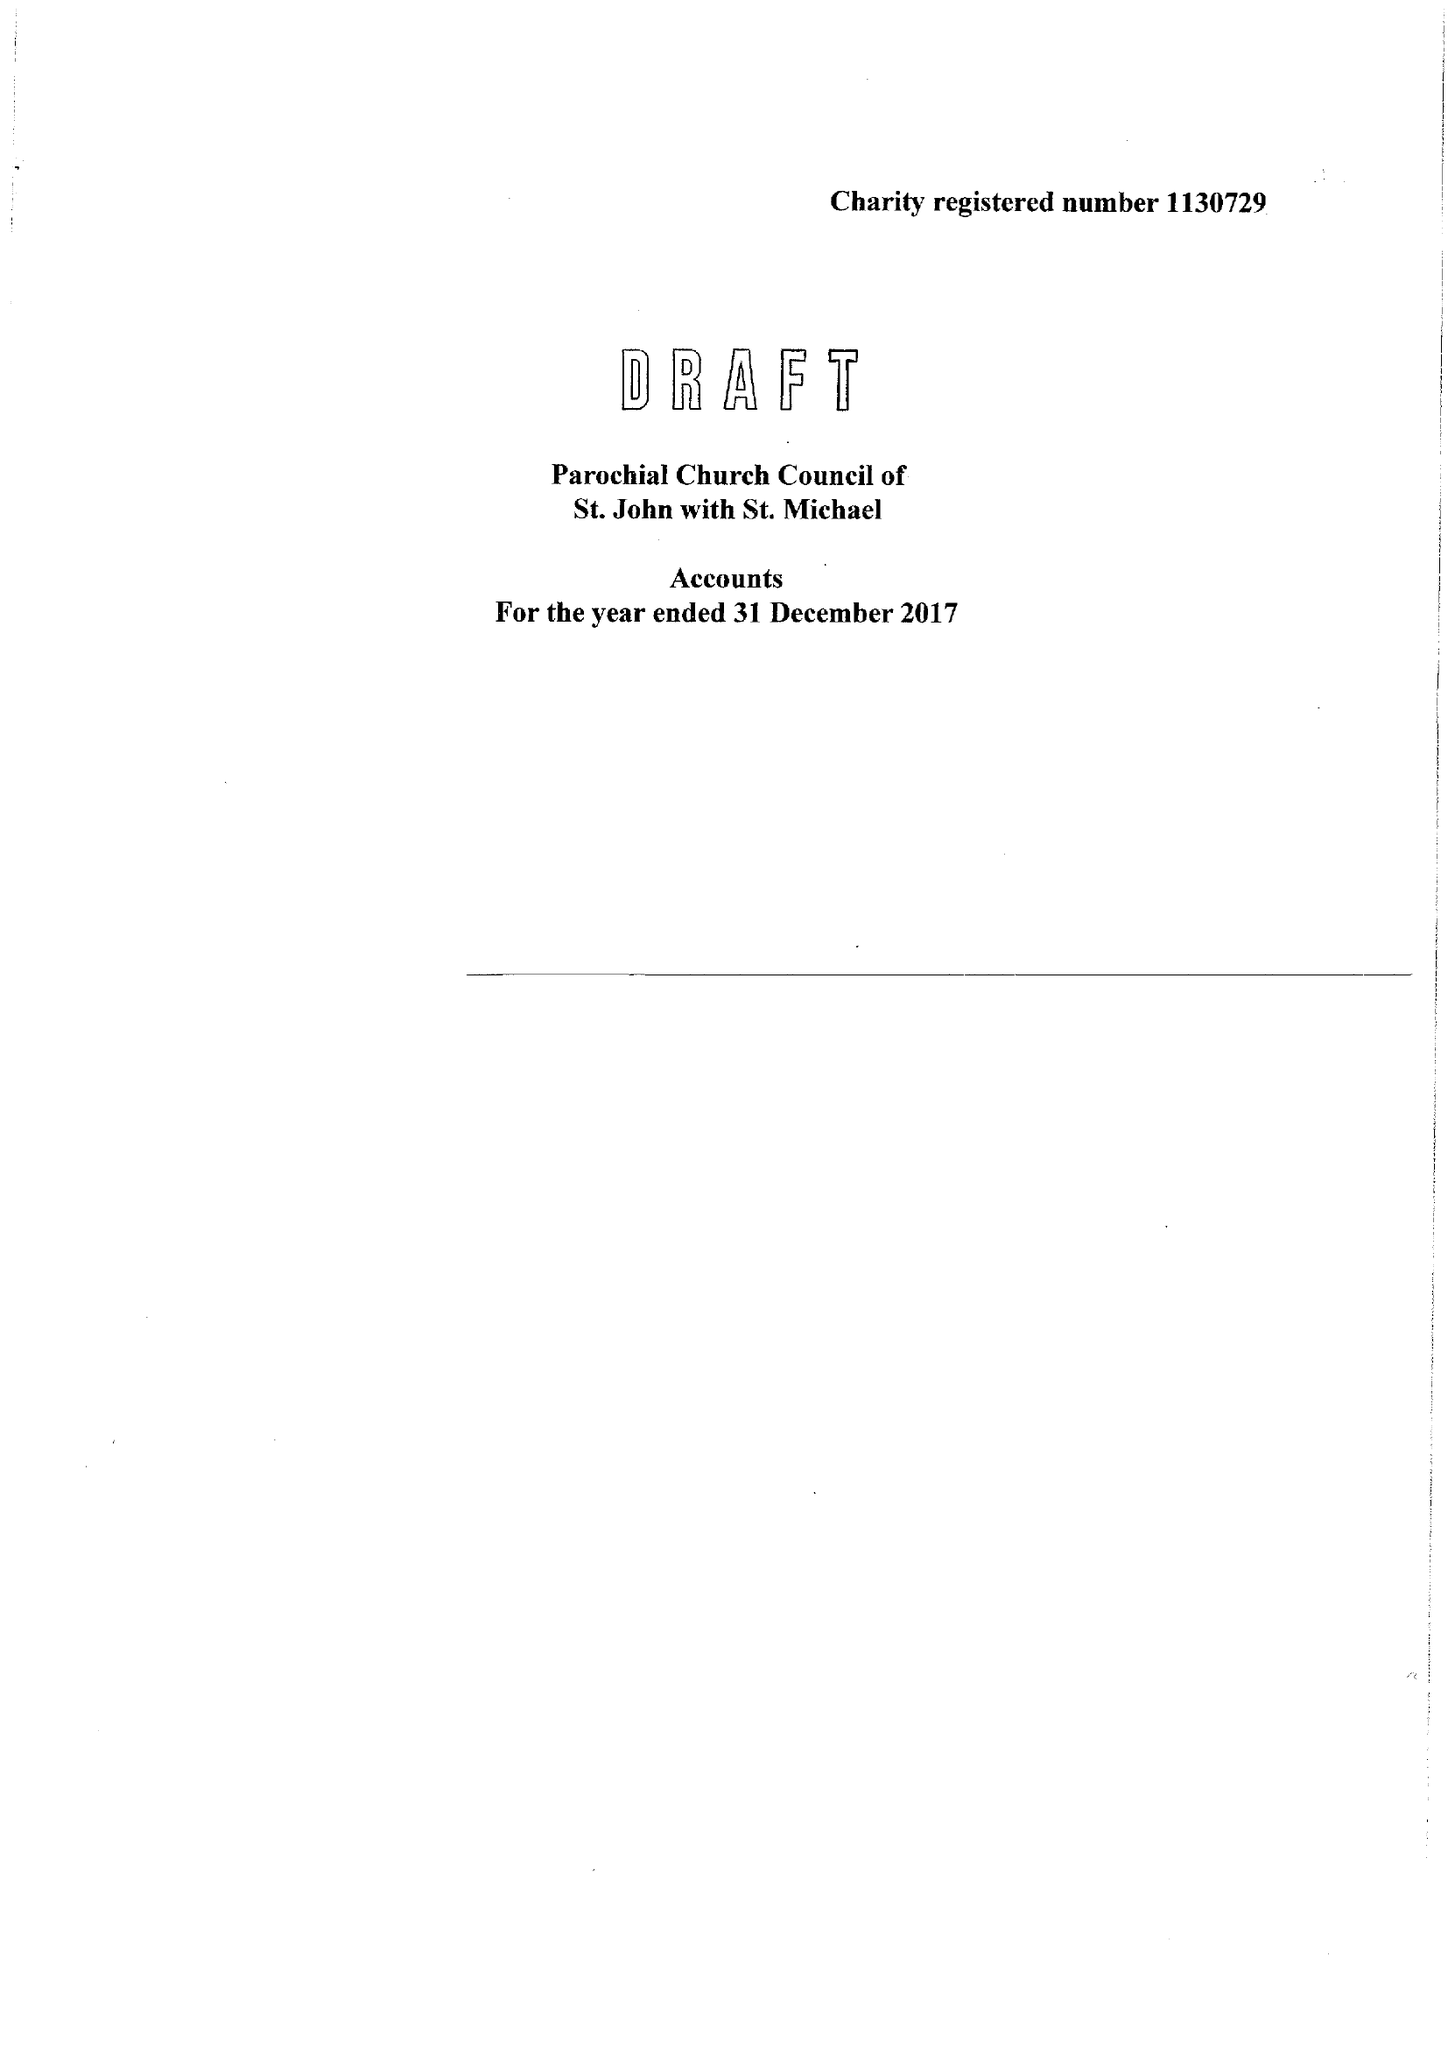What is the value for the spending_annually_in_british_pounds?
Answer the question using a single word or phrase. 169262.00 